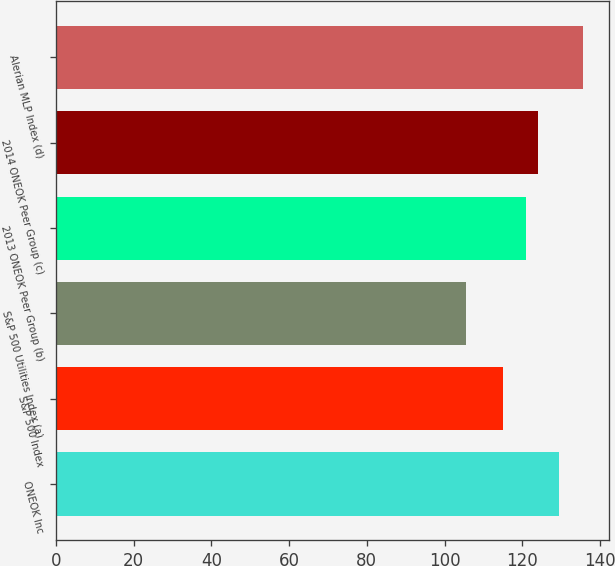Convert chart to OTSL. <chart><loc_0><loc_0><loc_500><loc_500><bar_chart><fcel>ONEOK Inc<fcel>S&P 500 Index<fcel>S&P 500 Utilities Index (a)<fcel>2013 ONEOK Peer Group (b)<fcel>2014 ONEOK Peer Group (c)<fcel>Alerian MLP Index (d)<nl><fcel>129.37<fcel>115.08<fcel>105.49<fcel>120.97<fcel>124.1<fcel>135.63<nl></chart> 